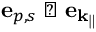<formula> <loc_0><loc_0><loc_500><loc_500>e _ { p , s } \perp e _ { \mathbf { k } _ { \| } }</formula> 